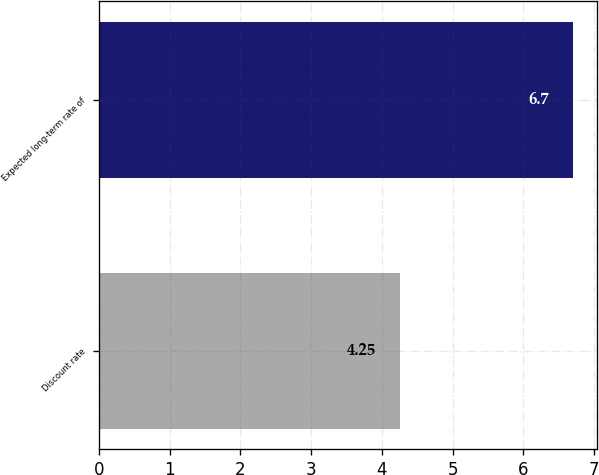Convert chart. <chart><loc_0><loc_0><loc_500><loc_500><bar_chart><fcel>Discount rate<fcel>Expected long-term rate of<nl><fcel>4.25<fcel>6.7<nl></chart> 